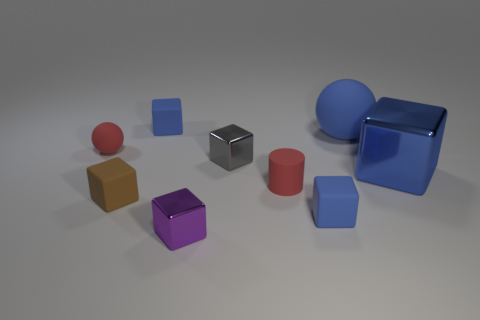What color is the tiny matte object that is left of the red rubber cylinder and in front of the tiny cylinder?
Provide a short and direct response. Brown. What number of blue shiny things are behind the matte sphere right of the small red sphere?
Keep it short and to the point. 0. What is the size of the blue object that is both behind the brown cube and in front of the blue sphere?
Offer a very short reply. Large. Is there a small rubber object that has the same color as the tiny rubber sphere?
Provide a succinct answer. Yes. Do the red rubber thing that is to the left of the purple thing and the red matte cylinder have the same size?
Give a very brief answer. Yes. The tiny metal thing behind the big shiny object has what shape?
Give a very brief answer. Cube. There is a matte ball to the right of the small red rubber ball; is it the same color as the large cube?
Your response must be concise. Yes. What is the color of the small block that is the same material as the gray object?
Keep it short and to the point. Purple. What size is the blue matte thing that is to the left of the gray object?
Offer a very short reply. Small. Does the large blue ball have the same material as the small sphere?
Your response must be concise. Yes. 